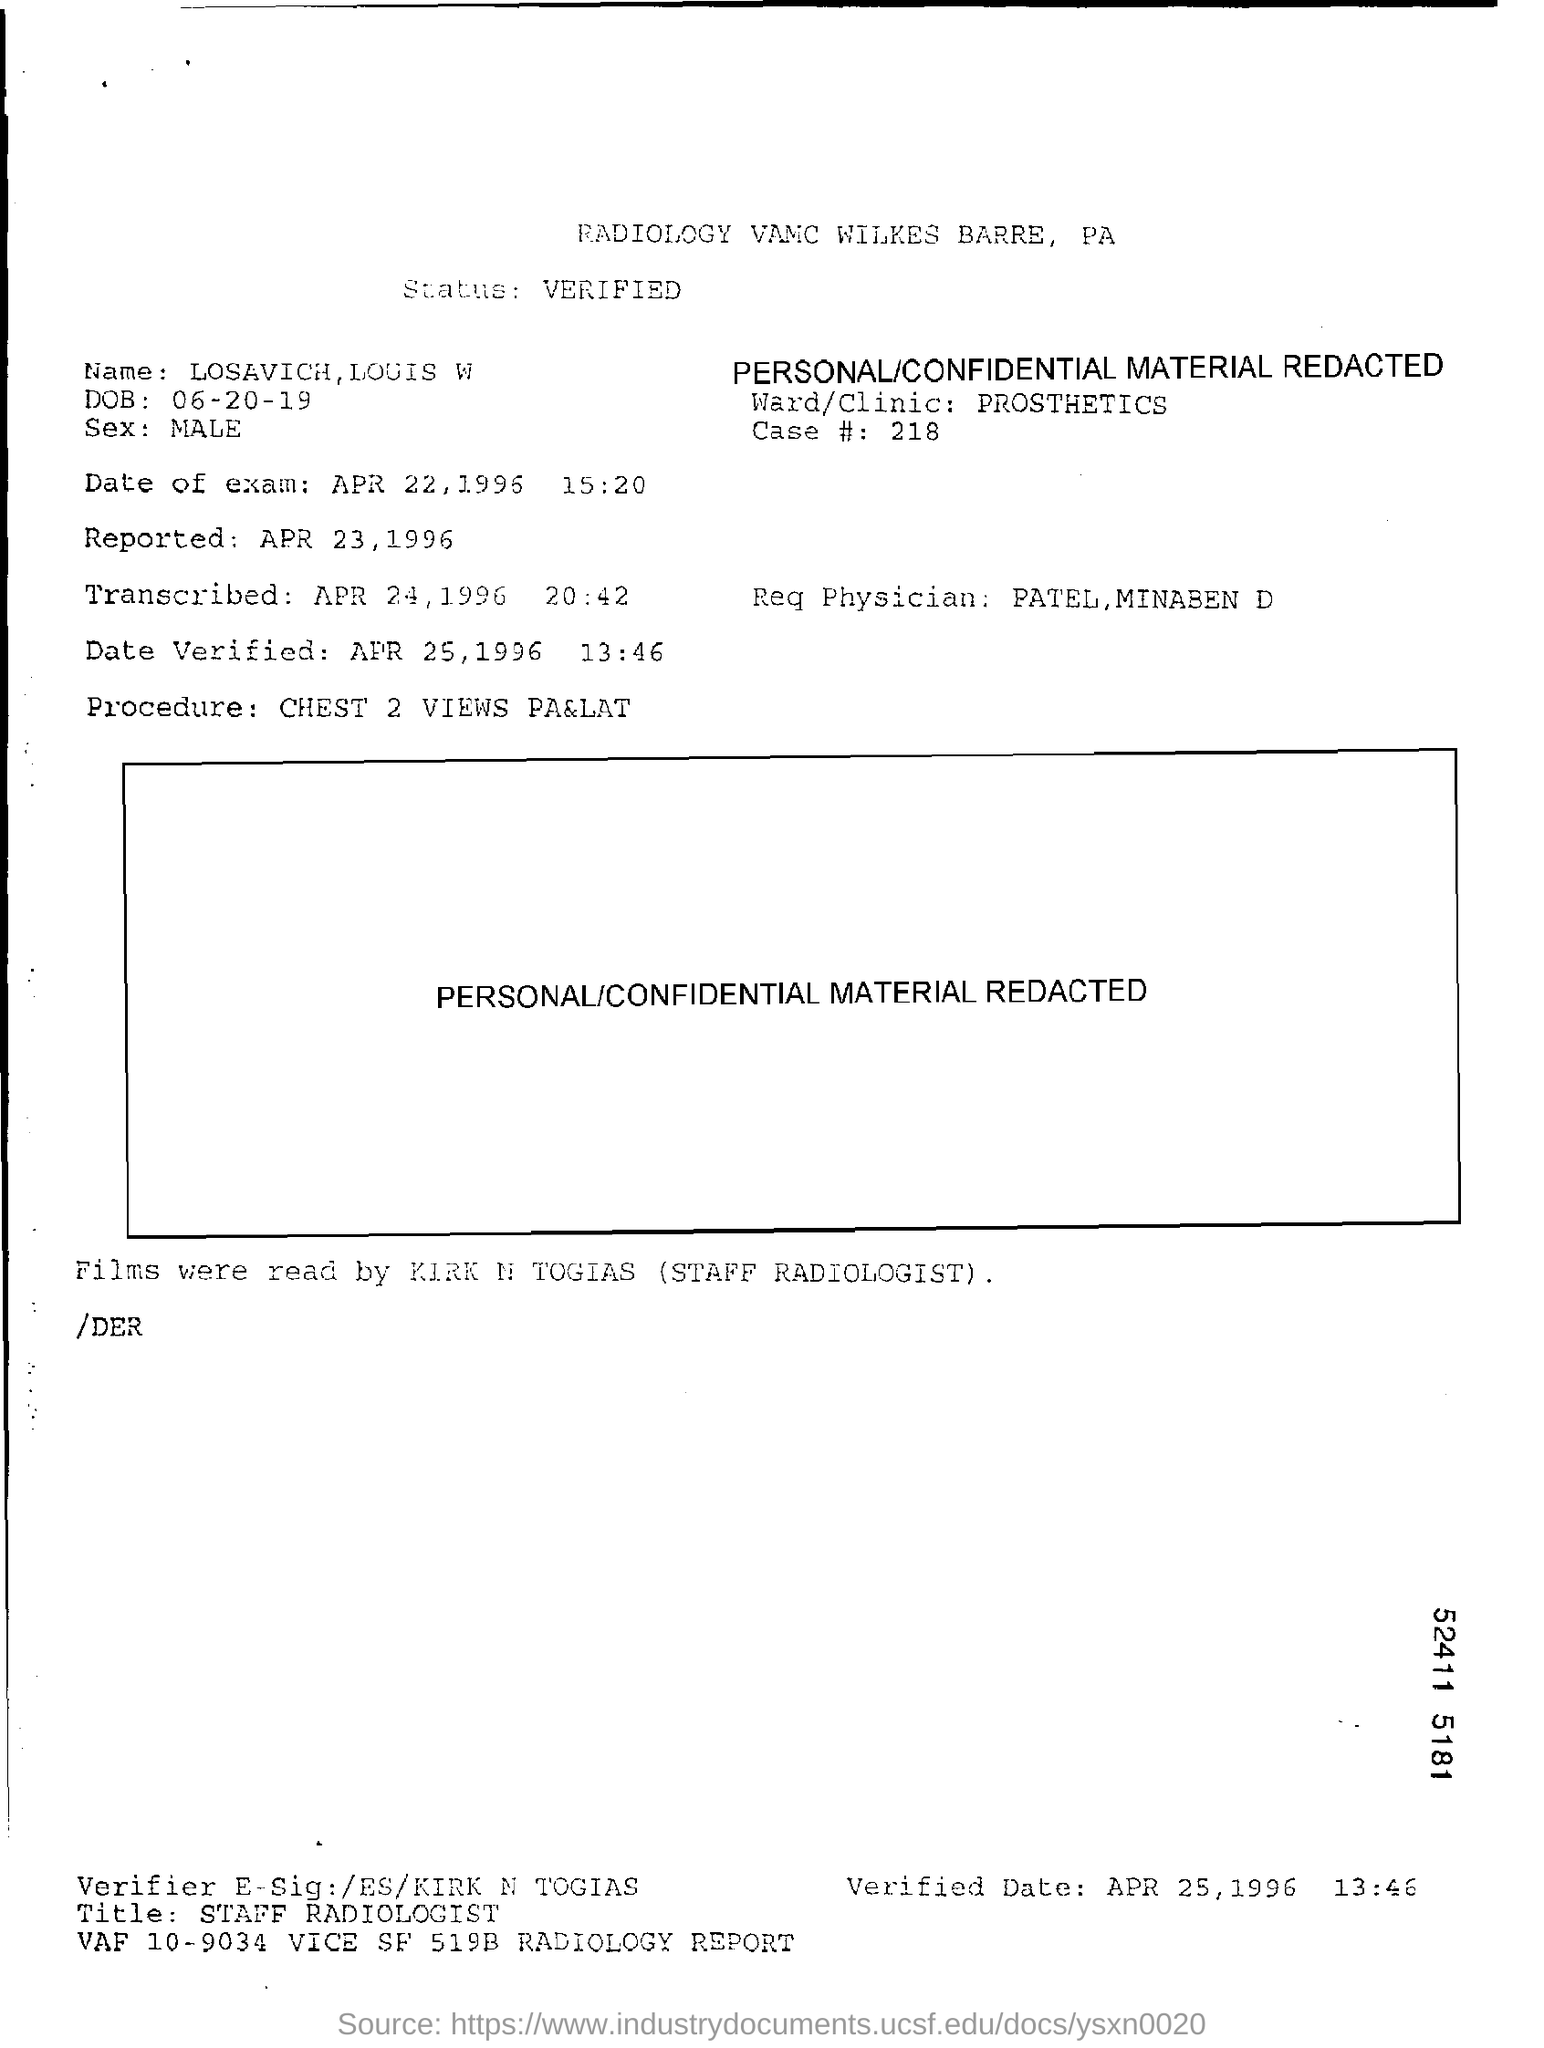Outline some significant characteristics in this image. The date of the exam is April 22, 1996. The reqesting physician is named Patel and the second physician is named Minaben. The date of the verification was April 25, 1996. The procedure involves two chest views, a PA view and a LAT view. The status is verified. 